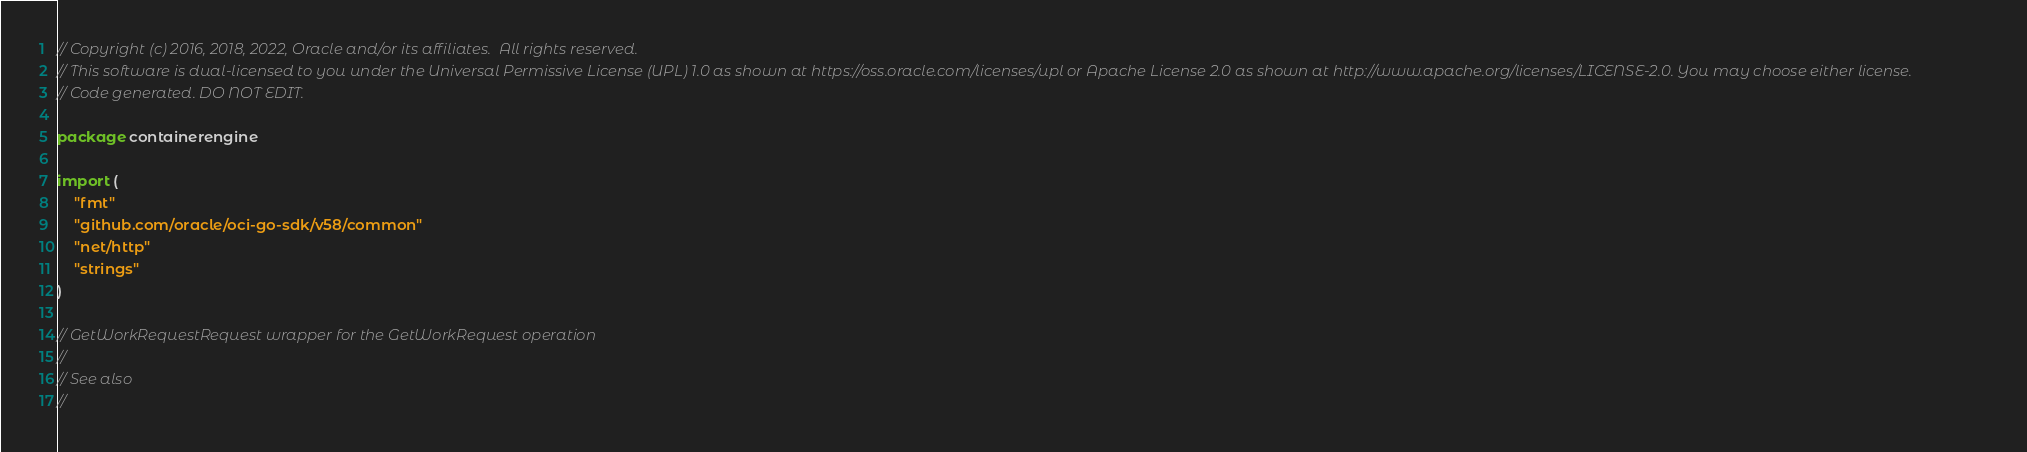<code> <loc_0><loc_0><loc_500><loc_500><_Go_>// Copyright (c) 2016, 2018, 2022, Oracle and/or its affiliates.  All rights reserved.
// This software is dual-licensed to you under the Universal Permissive License (UPL) 1.0 as shown at https://oss.oracle.com/licenses/upl or Apache License 2.0 as shown at http://www.apache.org/licenses/LICENSE-2.0. You may choose either license.
// Code generated. DO NOT EDIT.

package containerengine

import (
	"fmt"
	"github.com/oracle/oci-go-sdk/v58/common"
	"net/http"
	"strings"
)

// GetWorkRequestRequest wrapper for the GetWorkRequest operation
//
// See also
//</code> 